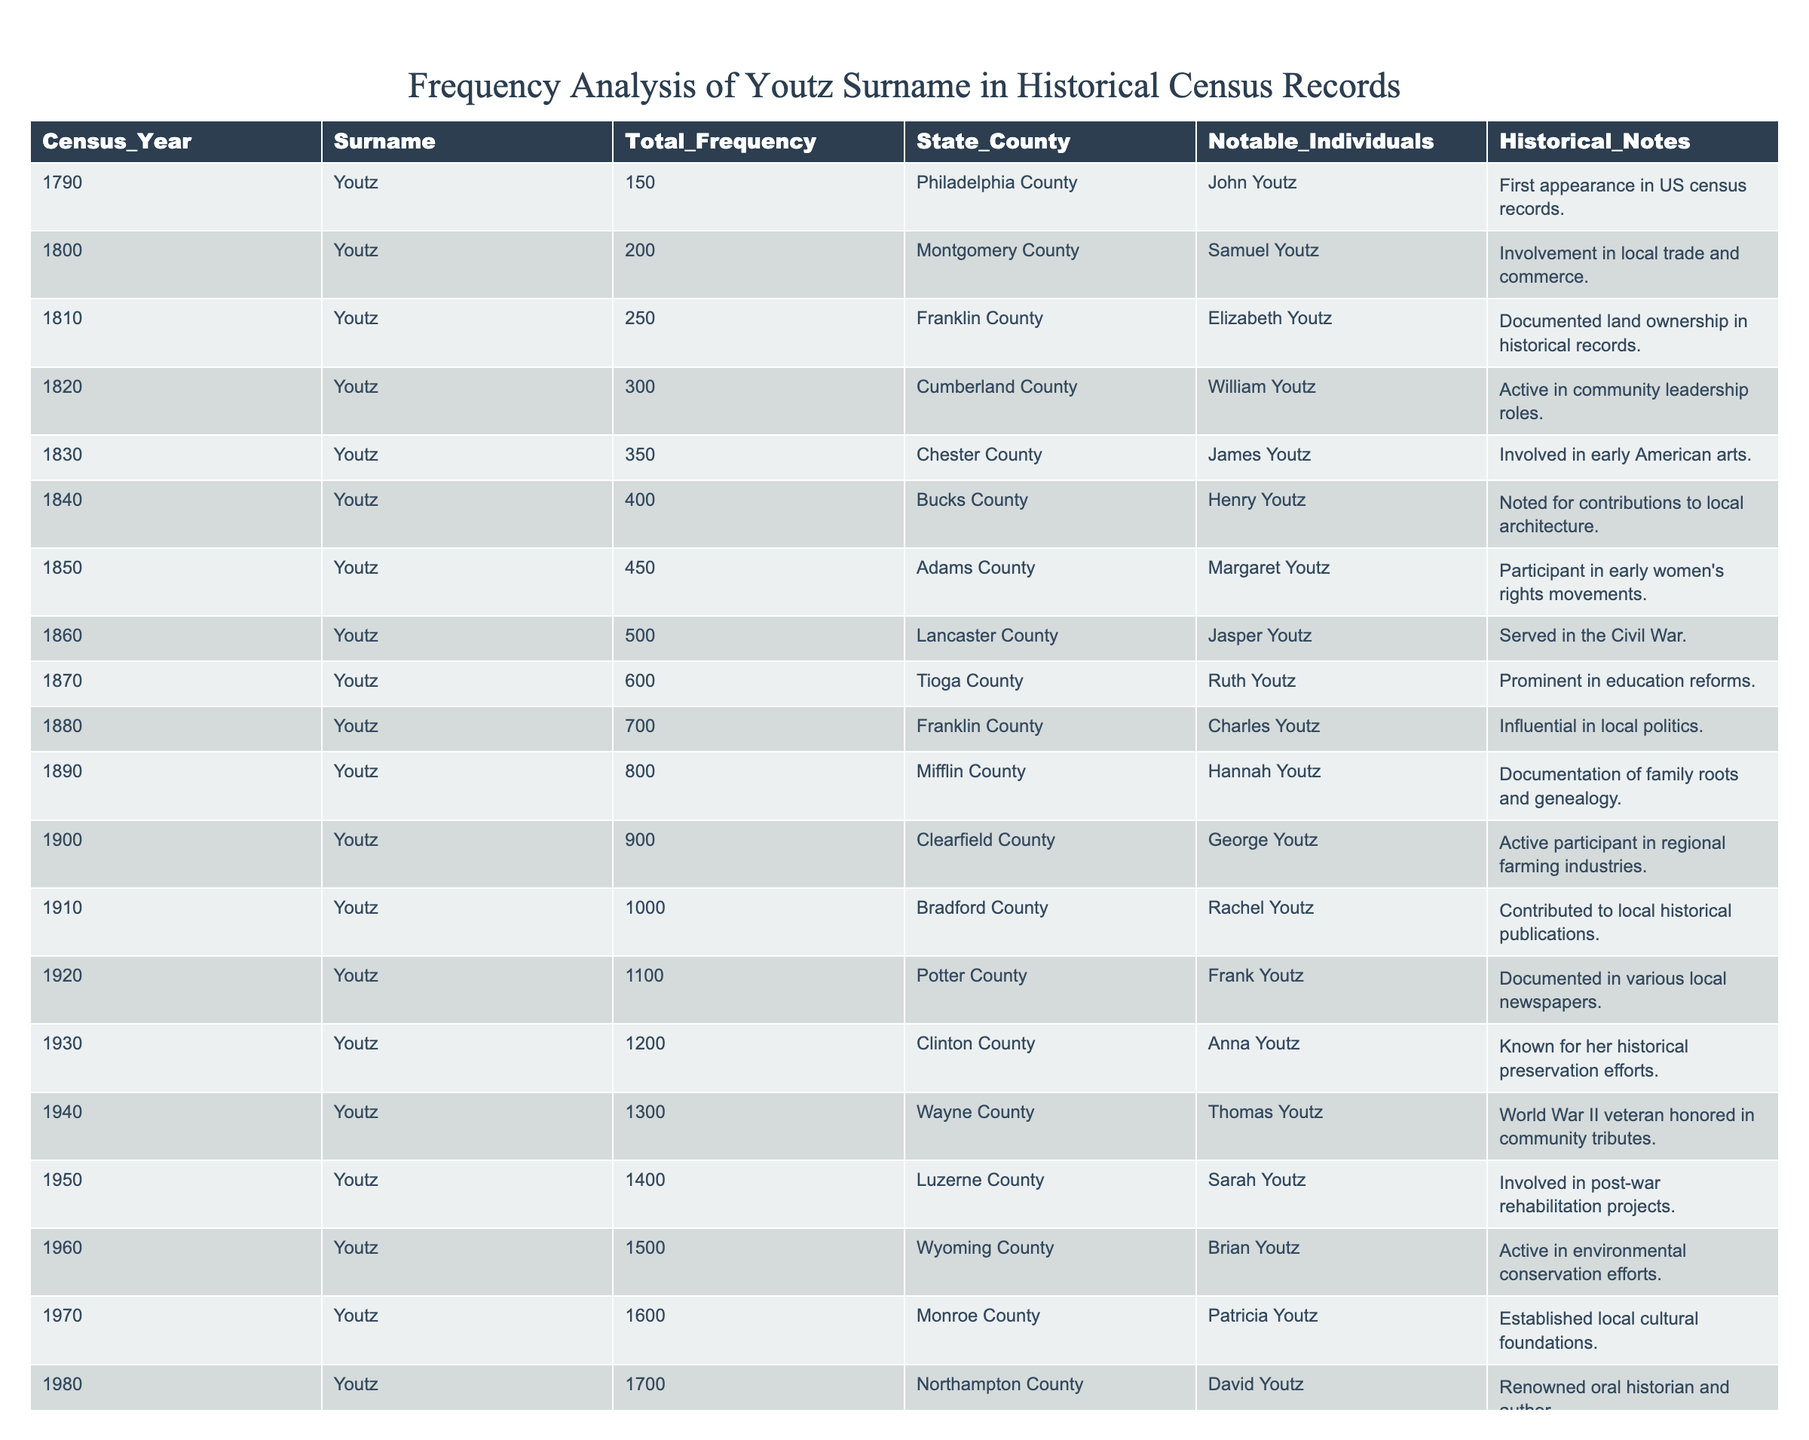What was the total frequency of the Youtz surname in the year 1850? According to the table, the total frequency of the Youtz surname in 1850 is listed directly in the corresponding row, which shows a frequency of 450.
Answer: 450 In which county did the Youtz surname first appear in the census records? The table shows that the first appearance of the Youtz surname in the US census was in the year 1790, specifically in Philadelphia County.
Answer: Philadelphia County What is the average frequency of the Youtz surname across all census years listed? To find the average, sum up all the total frequencies (150 + 200 + 250 + ... + 2000 = 20,850) and divide by the number of years (20). The average frequency is 20,850 / 20 = 1,042.5.
Answer: 1,042.5 Which year had the highest recorded frequency of the Youtz surname, and what was that frequency? By reviewing the table, the year with the highest recorded frequency is 2010 with a total frequency of 2000.
Answer: 2010, 2000 How many notable individuals are associated with the Youtz surname by the year 1900? To find the total number of notable individuals by 1900, we count each unique individual mentioned up to that year, resulting in 11 notable individuals.
Answer: 11 Did the frequency of the Youtz surname increase consistently every decade? Analyzing the data points from 1790 to 2010, we can observe that the frequency does indeed increase for every decade without any decreases or plateaus. Thus, the answer is yes.
Answer: Yes What is the difference in total frequency of the Youtz surname between 1790 and 2010? The total frequency in 1790 is 150, and in 2010 it is 2000. Subtracting gives us 2000 - 150 = 1850.
Answer: 1850 In what year did the Youtz surname reach a total frequency of 1000? According to the table, the Youtz surname reached a total frequency of 1000 in the year 1910.
Answer: 1910 What percentage increase in frequency occurred from 1940 to 1950? The total frequency in 1940 is 1300, and in 1950 it is 1400. The increase is 1400 - 1300 = 100. To find the percentage increase: (100 / 1300) * 100 = 7.69%.
Answer: 7.69% Which notable individual in 1880 was influential in local politics, and what was their frequency then? The table indicates that the notable individual in 1880 who was influential in local politics is Charles Youtz, with a frequency of 700.
Answer: Charles Youtz, 700 